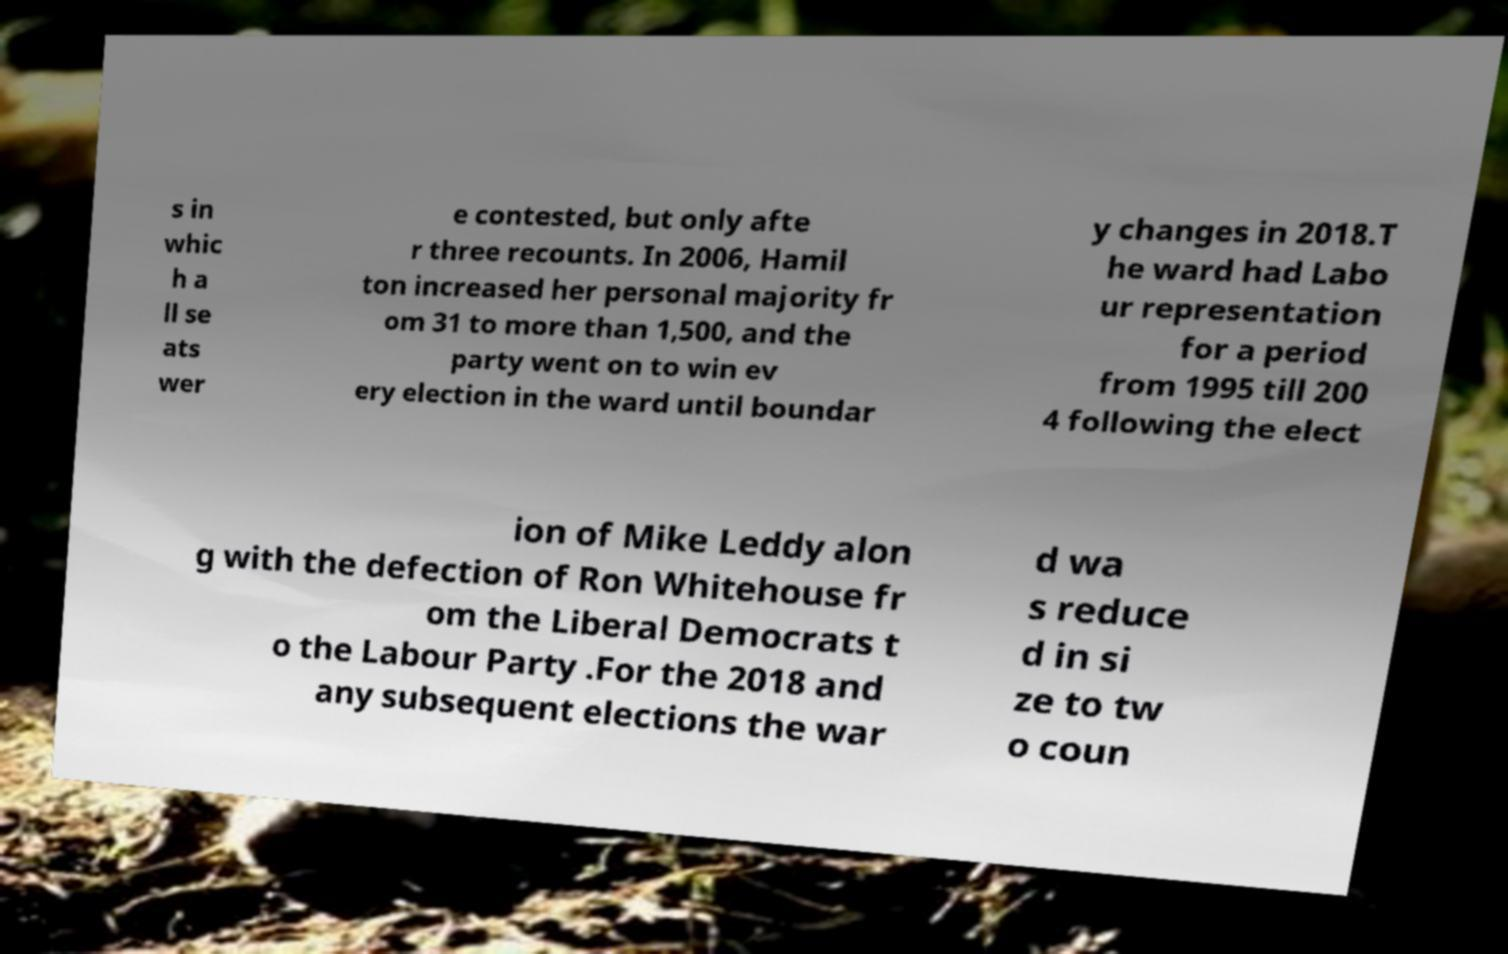Could you extract and type out the text from this image? s in whic h a ll se ats wer e contested, but only afte r three recounts. In 2006, Hamil ton increased her personal majority fr om 31 to more than 1,500, and the party went on to win ev ery election in the ward until boundar y changes in 2018.T he ward had Labo ur representation for a period from 1995 till 200 4 following the elect ion of Mike Leddy alon g with the defection of Ron Whitehouse fr om the Liberal Democrats t o the Labour Party .For the 2018 and any subsequent elections the war d wa s reduce d in si ze to tw o coun 